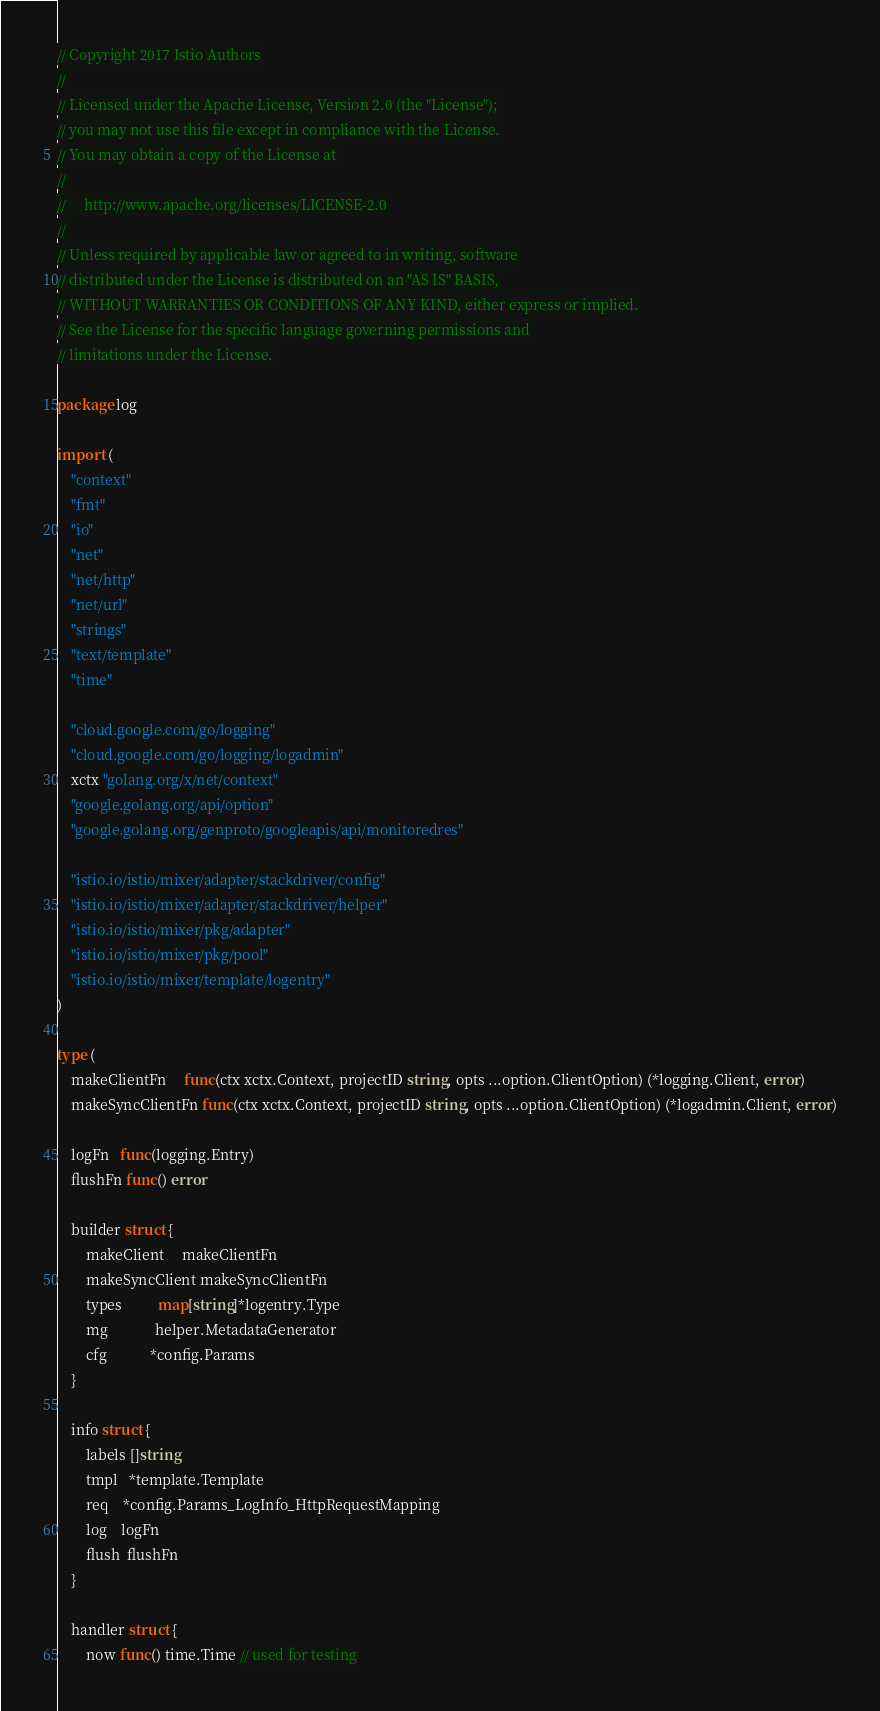Convert code to text. <code><loc_0><loc_0><loc_500><loc_500><_Go_>// Copyright 2017 Istio Authors
//
// Licensed under the Apache License, Version 2.0 (the "License");
// you may not use this file except in compliance with the License.
// You may obtain a copy of the License at
//
//     http://www.apache.org/licenses/LICENSE-2.0
//
// Unless required by applicable law or agreed to in writing, software
// distributed under the License is distributed on an "AS IS" BASIS,
// WITHOUT WARRANTIES OR CONDITIONS OF ANY KIND, either express or implied.
// See the License for the specific language governing permissions and
// limitations under the License.

package log

import (
	"context"
	"fmt"
	"io"
	"net"
	"net/http"
	"net/url"
	"strings"
	"text/template"
	"time"

	"cloud.google.com/go/logging"
	"cloud.google.com/go/logging/logadmin"
	xctx "golang.org/x/net/context"
	"google.golang.org/api/option"
	"google.golang.org/genproto/googleapis/api/monitoredres"

	"istio.io/istio/mixer/adapter/stackdriver/config"
	"istio.io/istio/mixer/adapter/stackdriver/helper"
	"istio.io/istio/mixer/pkg/adapter"
	"istio.io/istio/mixer/pkg/pool"
	"istio.io/istio/mixer/template/logentry"
)

type (
	makeClientFn     func(ctx xctx.Context, projectID string, opts ...option.ClientOption) (*logging.Client, error)
	makeSyncClientFn func(ctx xctx.Context, projectID string, opts ...option.ClientOption) (*logadmin.Client, error)

	logFn   func(logging.Entry)
	flushFn func() error

	builder struct {
		makeClient     makeClientFn
		makeSyncClient makeSyncClientFn
		types          map[string]*logentry.Type
		mg             helper.MetadataGenerator
		cfg            *config.Params
	}

	info struct {
		labels []string
		tmpl   *template.Template
		req    *config.Params_LogInfo_HttpRequestMapping
		log    logFn
		flush  flushFn
	}

	handler struct {
		now func() time.Time // used for testing
</code> 